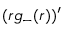<formula> <loc_0><loc_0><loc_500><loc_500>( r g _ { - } ( r ) ) ^ { \prime }</formula> 